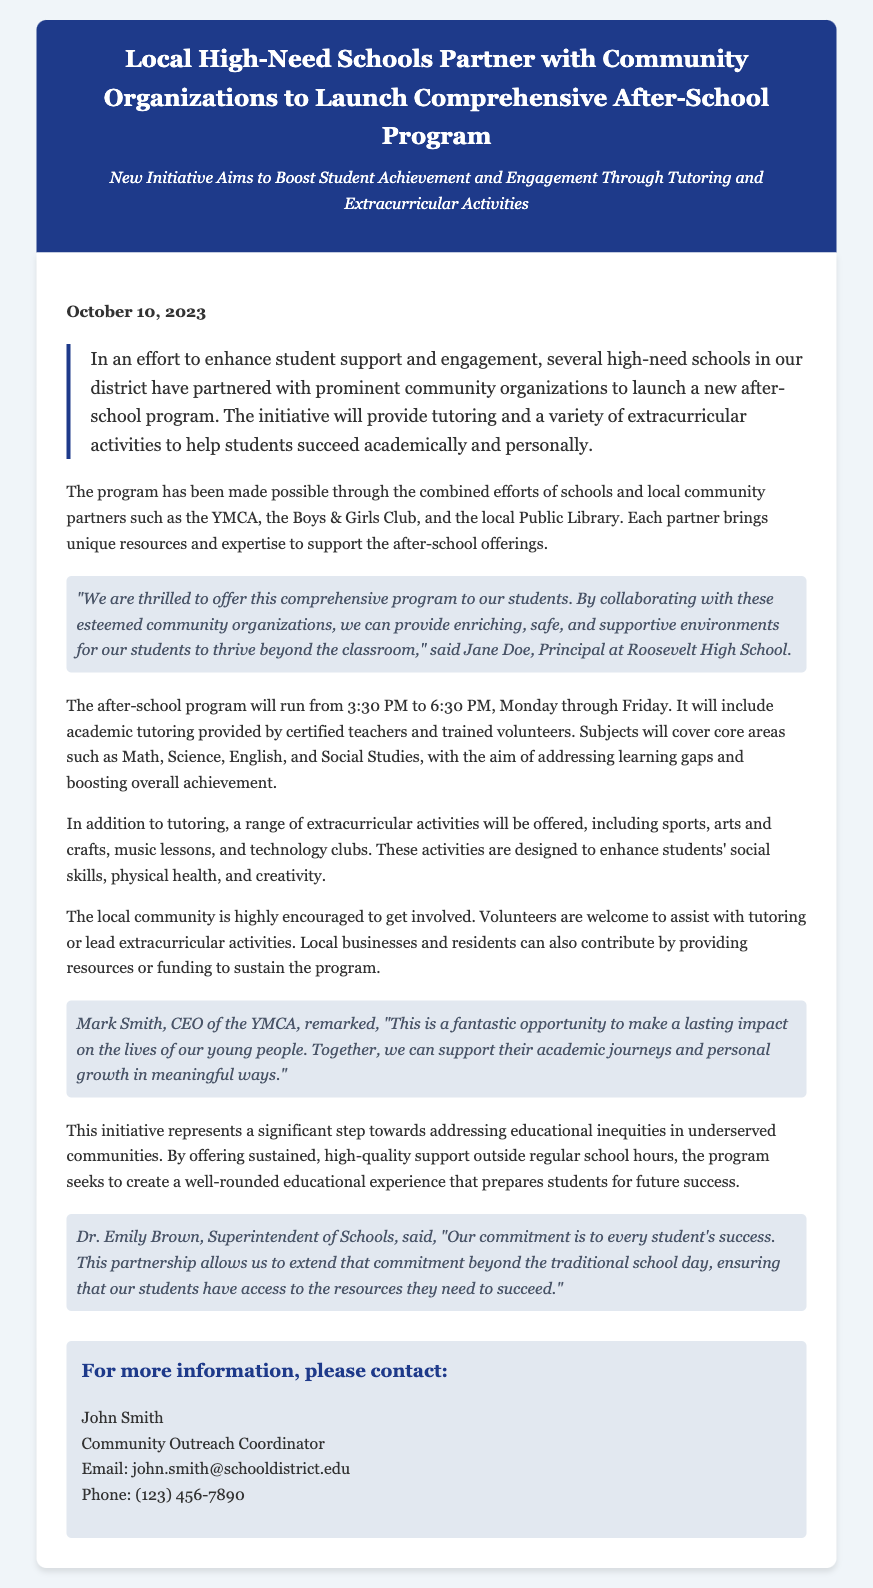What is the launch date of the program? The launch date is stated as October 10, 2023.
Answer: October 10, 2023 What organization is the CEO mentioned in the press release from? The CEO, Mark Smith, is associated with the YMCA.
Answer: YMCA What time does the after-school program run? The document specifies that the program runs from 3:30 PM to 6:30 PM.
Answer: 3:30 PM to 6:30 PM Which subjects will the academic tutoring cover? The subjects mentioned include Math, Science, English, and Social Studies.
Answer: Math, Science, English, Social Studies What is the name of the Principal of Roosevelt High School? The Principal's name is Jane Doe.
Answer: Jane Doe How many community organizations are mentioned as partners? The document mentions three community organizations—YMCA, Boys & Girls Club, and the local Public Library.
Answer: Three What type of activities, besides tutoring, will be included in the program? The program will include extracurricular activities such as sports, arts and crafts, music lessons, and technology clubs.
Answer: Sports, arts and crafts, music lessons, technology clubs What is the main goal of the initiative described in the press release? The main goal is to enhance student support and engagement through after-school programs.
Answer: Enhance student support and engagement Who should be contacted for more information about the program? The contact person for more information is John Smith.
Answer: John Smith 